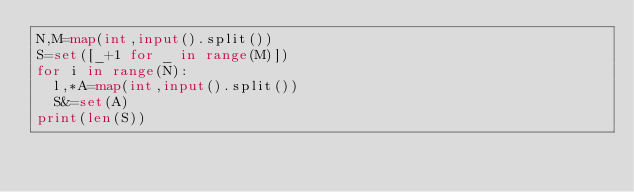<code> <loc_0><loc_0><loc_500><loc_500><_Python_>N,M=map(int,input().split())
S=set([_+1 for _ in range(M)])
for i in range(N):
  l,*A=map(int,input().split())
  S&=set(A)
print(len(S))</code> 